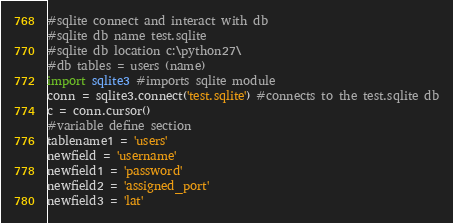Convert code to text. <code><loc_0><loc_0><loc_500><loc_500><_Python_>#sqlite connect and interact with db
#sqlite db name test.sqlite
#sqlite db location c:\python27\
#db tables = users (name)
import sqlite3 #imports sqlite module
conn = sqlite3.connect('test.sqlite') #connects to the test.sqlite db
c = conn.cursor()
#variable define section
tablename1 = 'users'
newfield = 'username'
newfield1 = 'password'
newfield2 = 'assigned_port'
newfield3 = 'lat'</code> 